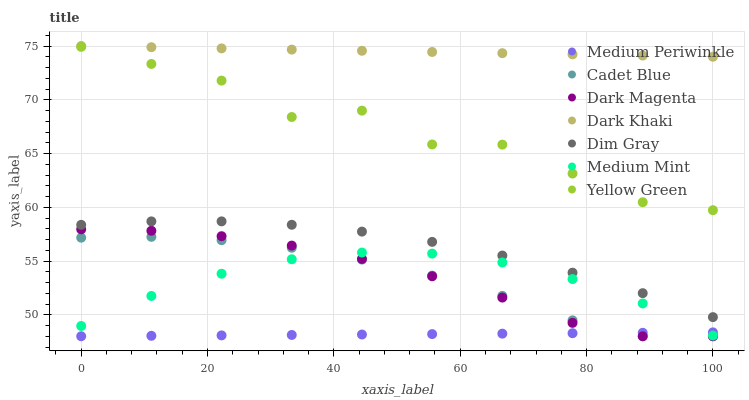Does Medium Periwinkle have the minimum area under the curve?
Answer yes or no. Yes. Does Dark Khaki have the maximum area under the curve?
Answer yes or no. Yes. Does Dim Gray have the minimum area under the curve?
Answer yes or no. No. Does Dim Gray have the maximum area under the curve?
Answer yes or no. No. Is Medium Periwinkle the smoothest?
Answer yes or no. Yes. Is Yellow Green the roughest?
Answer yes or no. Yes. Is Dim Gray the smoothest?
Answer yes or no. No. Is Dim Gray the roughest?
Answer yes or no. No. Does Dark Magenta have the lowest value?
Answer yes or no. Yes. Does Dim Gray have the lowest value?
Answer yes or no. No. Does Dark Khaki have the highest value?
Answer yes or no. Yes. Does Dim Gray have the highest value?
Answer yes or no. No. Is Dim Gray less than Dark Khaki?
Answer yes or no. Yes. Is Yellow Green greater than Dim Gray?
Answer yes or no. Yes. Does Cadet Blue intersect Medium Mint?
Answer yes or no. Yes. Is Cadet Blue less than Medium Mint?
Answer yes or no. No. Is Cadet Blue greater than Medium Mint?
Answer yes or no. No. Does Dim Gray intersect Dark Khaki?
Answer yes or no. No. 